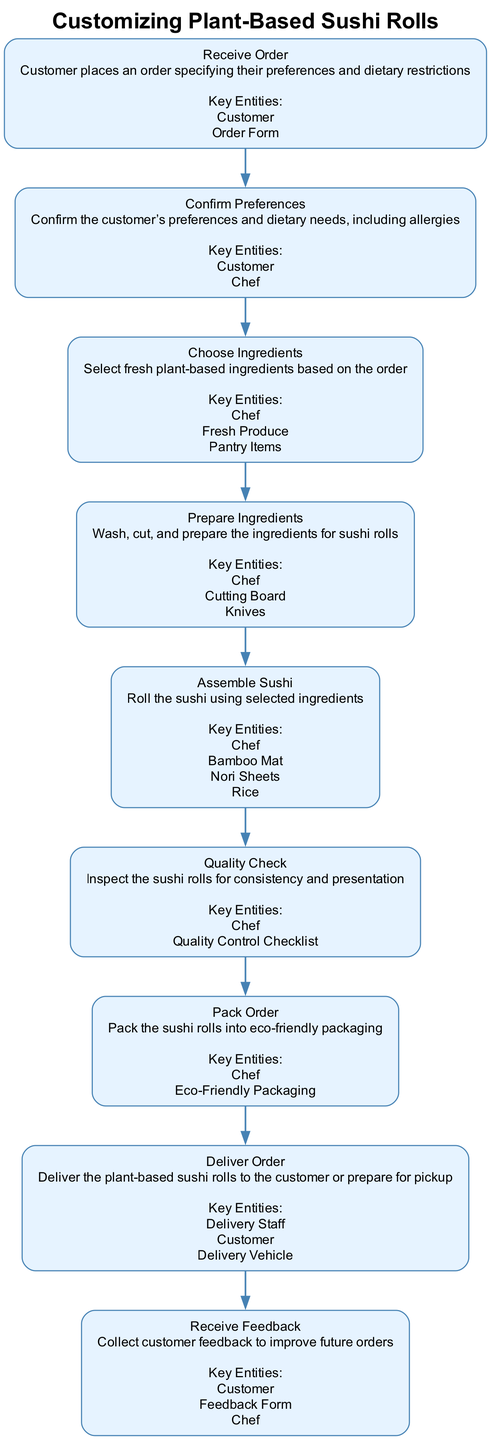What is the first step in the customization process? The first node in the diagram indicates "Receive Order," which is the starting point of the process.
Answer: Receive Order How many key entities are listed for the "Pack Order" step? By examining the "Pack Order" node, it lists one key entity, which is "Eco-Friendly Packaging."
Answer: One What is the last step before delivering the order? Following the flow from the previous steps, "Pack Order" is the step taken right before "Deliver Order," which confirms it's the last step.
Answer: Pack Order Which key entity is involved in the "Quality Check"? In the "Quality Check" node, it refers to the "Quality Control Checklist" as a key entity involved in this step.
Answer: Quality Control Checklist What step comes after "Choose Ingredients"? From the progression established in the flow chart, "Prepare Ingredients" directly follows "Choose Ingredients," indicating the next action taken.
Answer: Prepare Ingredients How many steps are there in total? Counting all the nodes in the diagram shows a total of eight distinct steps involved in the customization process.
Answer: Eight Which role is responsible for confirming customer preferences? The diagram indicates that the "Chef" is the key entity responsible for confirming customer preferences in the "Confirm Preferences" step.
Answer: Chef What is the purpose of the "Receive Feedback" step? The description in the diagram states that the purpose of this step is to "Collect customer feedback to improve future orders."
Answer: Collect customer feedback to improve future orders What is the main activity in the "Assemble Sushi" step? According to its description, the main activity conducted in this step is to "Roll the sushi using selected ingredients."
Answer: Roll the sushi using selected ingredients 